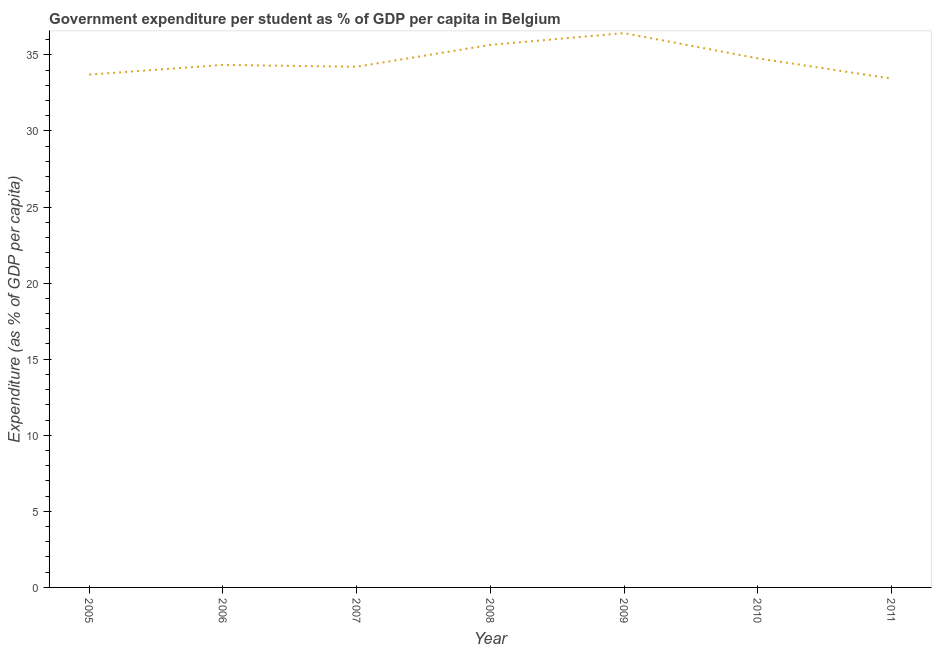What is the government expenditure per student in 2008?
Make the answer very short. 35.66. Across all years, what is the maximum government expenditure per student?
Provide a succinct answer. 36.43. Across all years, what is the minimum government expenditure per student?
Give a very brief answer. 33.44. In which year was the government expenditure per student maximum?
Give a very brief answer. 2009. What is the sum of the government expenditure per student?
Offer a terse response. 242.58. What is the difference between the government expenditure per student in 2005 and 2011?
Offer a terse response. 0.26. What is the average government expenditure per student per year?
Keep it short and to the point. 34.65. What is the median government expenditure per student?
Your answer should be very brief. 34.34. What is the ratio of the government expenditure per student in 2006 to that in 2008?
Provide a succinct answer. 0.96. Is the government expenditure per student in 2007 less than that in 2011?
Provide a succinct answer. No. What is the difference between the highest and the second highest government expenditure per student?
Provide a short and direct response. 0.77. Is the sum of the government expenditure per student in 2006 and 2007 greater than the maximum government expenditure per student across all years?
Your response must be concise. Yes. What is the difference between the highest and the lowest government expenditure per student?
Your response must be concise. 2.99. In how many years, is the government expenditure per student greater than the average government expenditure per student taken over all years?
Your response must be concise. 3. How many lines are there?
Give a very brief answer. 1. Does the graph contain any zero values?
Keep it short and to the point. No. Does the graph contain grids?
Provide a succinct answer. No. What is the title of the graph?
Keep it short and to the point. Government expenditure per student as % of GDP per capita in Belgium. What is the label or title of the Y-axis?
Ensure brevity in your answer.  Expenditure (as % of GDP per capita). What is the Expenditure (as % of GDP per capita) in 2005?
Make the answer very short. 33.71. What is the Expenditure (as % of GDP per capita) in 2006?
Your response must be concise. 34.34. What is the Expenditure (as % of GDP per capita) of 2007?
Give a very brief answer. 34.22. What is the Expenditure (as % of GDP per capita) of 2008?
Offer a very short reply. 35.66. What is the Expenditure (as % of GDP per capita) in 2009?
Your response must be concise. 36.43. What is the Expenditure (as % of GDP per capita) of 2010?
Offer a very short reply. 34.77. What is the Expenditure (as % of GDP per capita) in 2011?
Your response must be concise. 33.44. What is the difference between the Expenditure (as % of GDP per capita) in 2005 and 2006?
Your response must be concise. -0.64. What is the difference between the Expenditure (as % of GDP per capita) in 2005 and 2007?
Give a very brief answer. -0.52. What is the difference between the Expenditure (as % of GDP per capita) in 2005 and 2008?
Your response must be concise. -1.95. What is the difference between the Expenditure (as % of GDP per capita) in 2005 and 2009?
Offer a terse response. -2.73. What is the difference between the Expenditure (as % of GDP per capita) in 2005 and 2010?
Provide a short and direct response. -1.07. What is the difference between the Expenditure (as % of GDP per capita) in 2005 and 2011?
Ensure brevity in your answer.  0.26. What is the difference between the Expenditure (as % of GDP per capita) in 2006 and 2007?
Make the answer very short. 0.12. What is the difference between the Expenditure (as % of GDP per capita) in 2006 and 2008?
Your answer should be compact. -1.32. What is the difference between the Expenditure (as % of GDP per capita) in 2006 and 2009?
Keep it short and to the point. -2.09. What is the difference between the Expenditure (as % of GDP per capita) in 2006 and 2010?
Offer a terse response. -0.43. What is the difference between the Expenditure (as % of GDP per capita) in 2006 and 2011?
Your response must be concise. 0.9. What is the difference between the Expenditure (as % of GDP per capita) in 2007 and 2008?
Your answer should be very brief. -1.44. What is the difference between the Expenditure (as % of GDP per capita) in 2007 and 2009?
Your answer should be compact. -2.21. What is the difference between the Expenditure (as % of GDP per capita) in 2007 and 2010?
Offer a very short reply. -0.55. What is the difference between the Expenditure (as % of GDP per capita) in 2007 and 2011?
Keep it short and to the point. 0.78. What is the difference between the Expenditure (as % of GDP per capita) in 2008 and 2009?
Your answer should be compact. -0.77. What is the difference between the Expenditure (as % of GDP per capita) in 2008 and 2010?
Offer a very short reply. 0.88. What is the difference between the Expenditure (as % of GDP per capita) in 2008 and 2011?
Ensure brevity in your answer.  2.21. What is the difference between the Expenditure (as % of GDP per capita) in 2009 and 2010?
Your answer should be very brief. 1.66. What is the difference between the Expenditure (as % of GDP per capita) in 2009 and 2011?
Offer a very short reply. 2.99. What is the difference between the Expenditure (as % of GDP per capita) in 2010 and 2011?
Provide a short and direct response. 1.33. What is the ratio of the Expenditure (as % of GDP per capita) in 2005 to that in 2008?
Offer a terse response. 0.94. What is the ratio of the Expenditure (as % of GDP per capita) in 2005 to that in 2009?
Offer a terse response. 0.93. What is the ratio of the Expenditure (as % of GDP per capita) in 2005 to that in 2010?
Ensure brevity in your answer.  0.97. What is the ratio of the Expenditure (as % of GDP per capita) in 2005 to that in 2011?
Your answer should be very brief. 1.01. What is the ratio of the Expenditure (as % of GDP per capita) in 2006 to that in 2007?
Offer a terse response. 1. What is the ratio of the Expenditure (as % of GDP per capita) in 2006 to that in 2008?
Give a very brief answer. 0.96. What is the ratio of the Expenditure (as % of GDP per capita) in 2006 to that in 2009?
Ensure brevity in your answer.  0.94. What is the ratio of the Expenditure (as % of GDP per capita) in 2007 to that in 2008?
Offer a terse response. 0.96. What is the ratio of the Expenditure (as % of GDP per capita) in 2007 to that in 2009?
Offer a terse response. 0.94. What is the ratio of the Expenditure (as % of GDP per capita) in 2007 to that in 2010?
Ensure brevity in your answer.  0.98. What is the ratio of the Expenditure (as % of GDP per capita) in 2007 to that in 2011?
Give a very brief answer. 1.02. What is the ratio of the Expenditure (as % of GDP per capita) in 2008 to that in 2009?
Your answer should be compact. 0.98. What is the ratio of the Expenditure (as % of GDP per capita) in 2008 to that in 2010?
Your answer should be compact. 1.02. What is the ratio of the Expenditure (as % of GDP per capita) in 2008 to that in 2011?
Keep it short and to the point. 1.07. What is the ratio of the Expenditure (as % of GDP per capita) in 2009 to that in 2010?
Provide a short and direct response. 1.05. What is the ratio of the Expenditure (as % of GDP per capita) in 2009 to that in 2011?
Keep it short and to the point. 1.09. What is the ratio of the Expenditure (as % of GDP per capita) in 2010 to that in 2011?
Your answer should be compact. 1.04. 